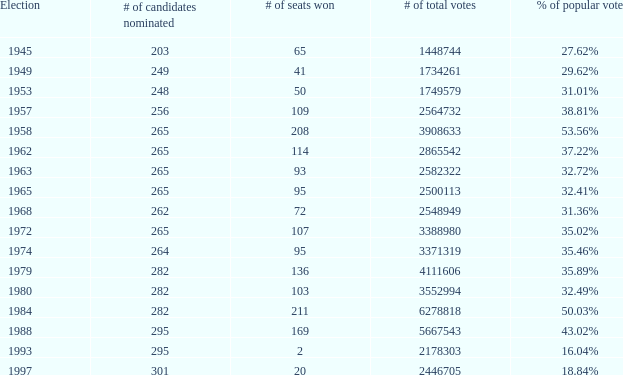What was the lowest # of total votes? 1448744.0. 